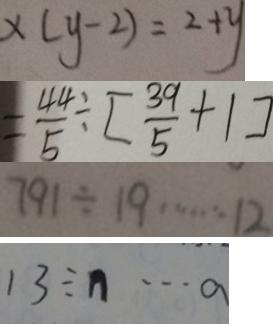Convert formula to latex. <formula><loc_0><loc_0><loc_500><loc_500>x ( y - 2 ) = 2 + y 
 = \frac { 4 4 } { 5 } \div [ \frac { 3 9 } { 5 } + 1 ] 
 7 9 1 \div 1 9 \cdots 1 2 
 1 3 \div n \cdots a</formula> 